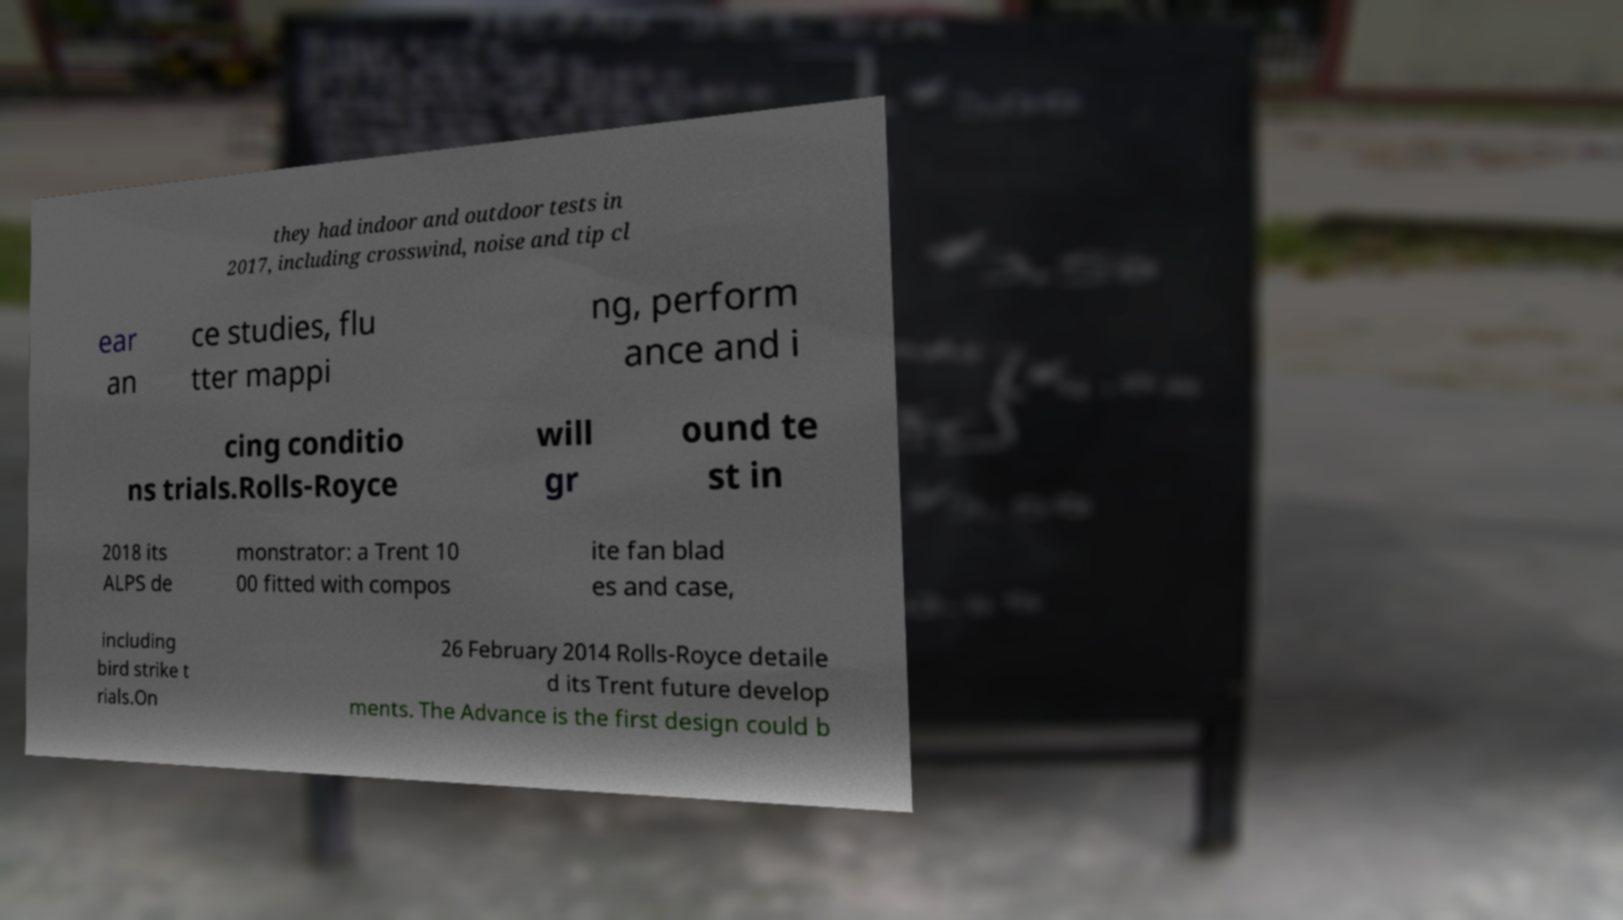Could you extract and type out the text from this image? they had indoor and outdoor tests in 2017, including crosswind, noise and tip cl ear an ce studies, flu tter mappi ng, perform ance and i cing conditio ns trials.Rolls-Royce will gr ound te st in 2018 its ALPS de monstrator: a Trent 10 00 fitted with compos ite fan blad es and case, including bird strike t rials.On 26 February 2014 Rolls-Royce detaile d its Trent future develop ments. The Advance is the first design could b 